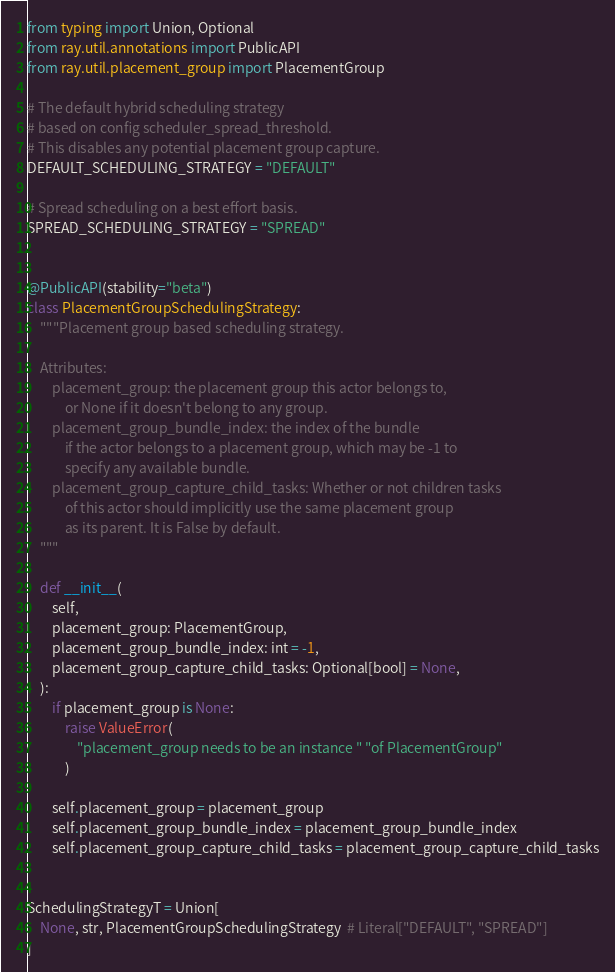Convert code to text. <code><loc_0><loc_0><loc_500><loc_500><_Python_>from typing import Union, Optional
from ray.util.annotations import PublicAPI
from ray.util.placement_group import PlacementGroup

# The default hybrid scheduling strategy
# based on config scheduler_spread_threshold.
# This disables any potential placement group capture.
DEFAULT_SCHEDULING_STRATEGY = "DEFAULT"

# Spread scheduling on a best effort basis.
SPREAD_SCHEDULING_STRATEGY = "SPREAD"


@PublicAPI(stability="beta")
class PlacementGroupSchedulingStrategy:
    """Placement group based scheduling strategy.

    Attributes:
        placement_group: the placement group this actor belongs to,
            or None if it doesn't belong to any group.
        placement_group_bundle_index: the index of the bundle
            if the actor belongs to a placement group, which may be -1 to
            specify any available bundle.
        placement_group_capture_child_tasks: Whether or not children tasks
            of this actor should implicitly use the same placement group
            as its parent. It is False by default.
    """

    def __init__(
        self,
        placement_group: PlacementGroup,
        placement_group_bundle_index: int = -1,
        placement_group_capture_child_tasks: Optional[bool] = None,
    ):
        if placement_group is None:
            raise ValueError(
                "placement_group needs to be an instance " "of PlacementGroup"
            )

        self.placement_group = placement_group
        self.placement_group_bundle_index = placement_group_bundle_index
        self.placement_group_capture_child_tasks = placement_group_capture_child_tasks


SchedulingStrategyT = Union[
    None, str, PlacementGroupSchedulingStrategy  # Literal["DEFAULT", "SPREAD"]
]
</code> 